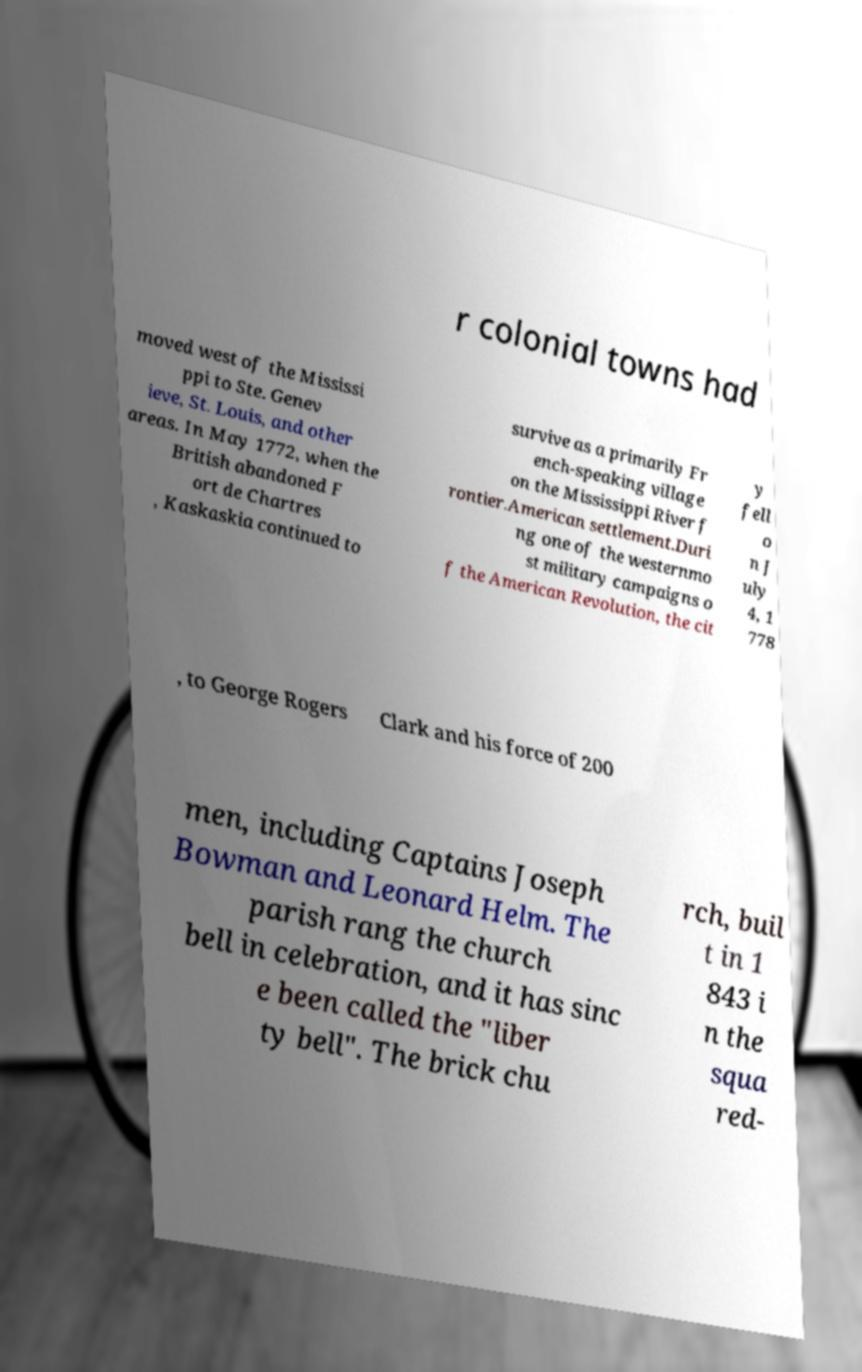Can you read and provide the text displayed in the image?This photo seems to have some interesting text. Can you extract and type it out for me? r colonial towns had moved west of the Mississi ppi to Ste. Genev ieve, St. Louis, and other areas. In May 1772, when the British abandoned F ort de Chartres , Kaskaskia continued to survive as a primarily Fr ench-speaking village on the Mississippi River f rontier.American settlement.Duri ng one of the westernmo st military campaigns o f the American Revolution, the cit y fell o n J uly 4, 1 778 , to George Rogers Clark and his force of 200 men, including Captains Joseph Bowman and Leonard Helm. The parish rang the church bell in celebration, and it has sinc e been called the "liber ty bell". The brick chu rch, buil t in 1 843 i n the squa red- 